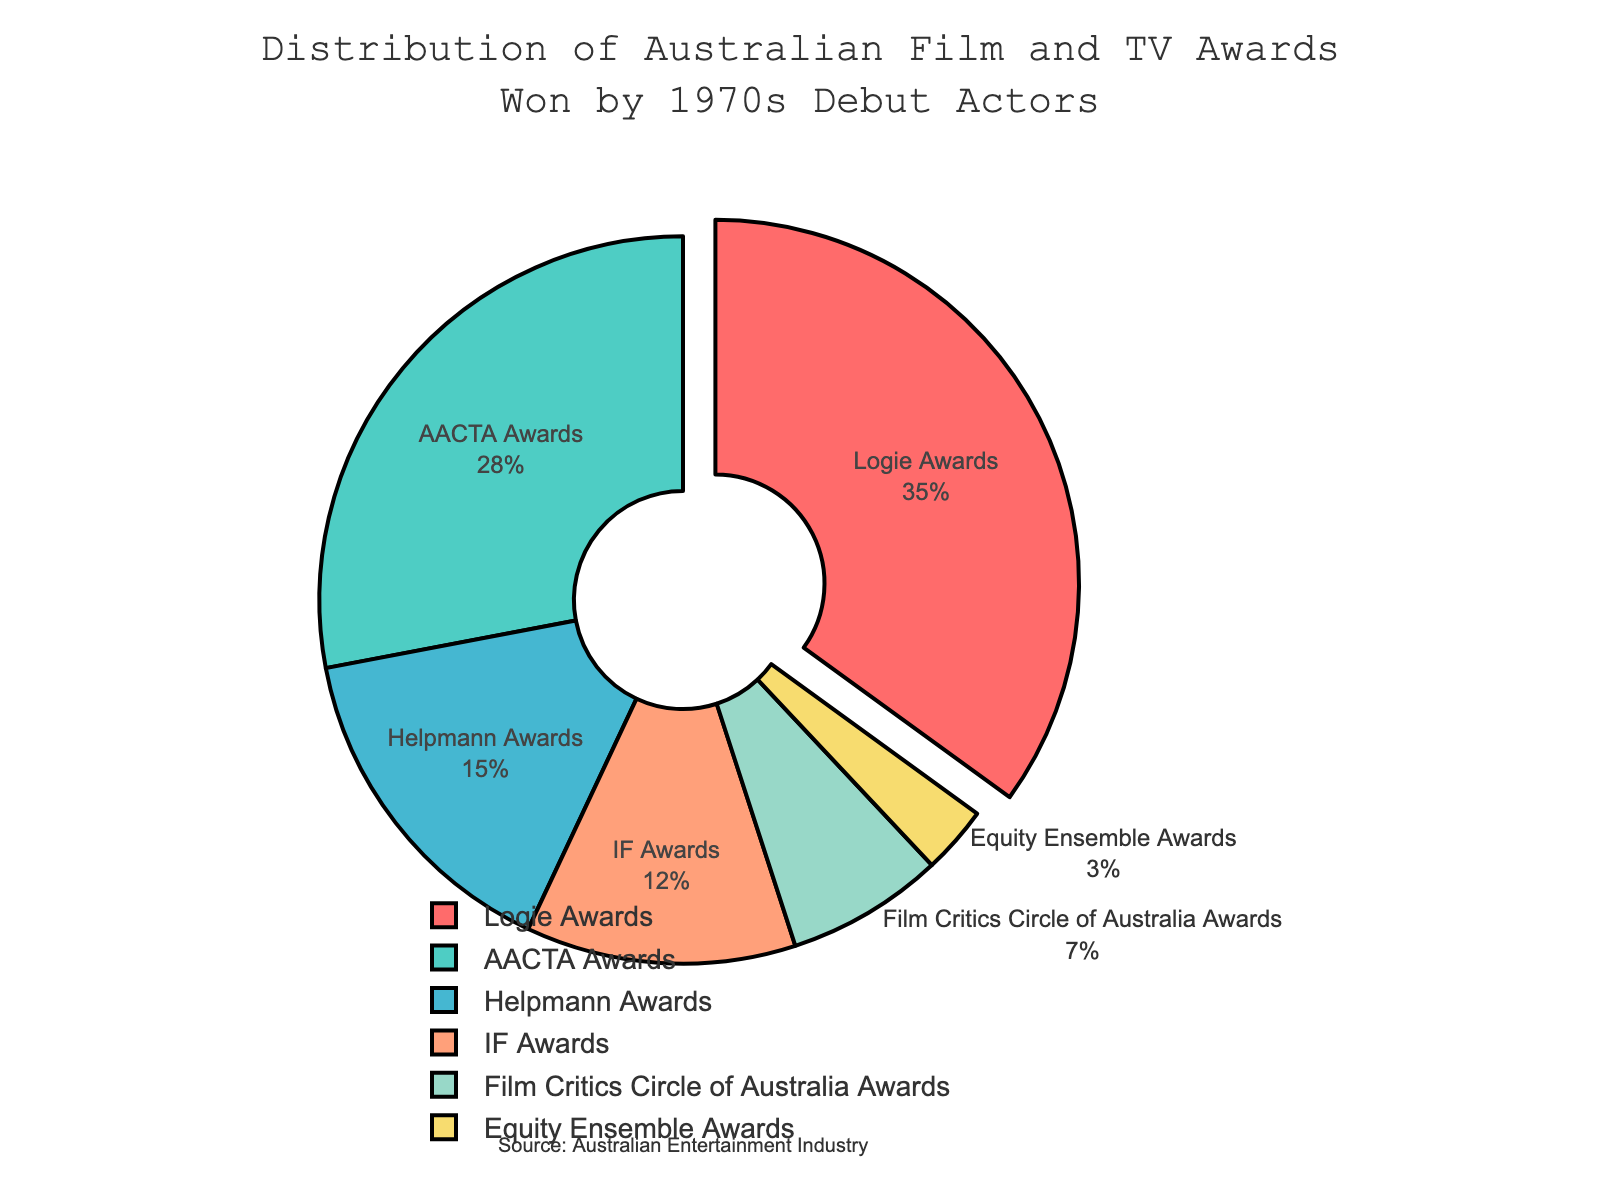What is the largest segment in the pie chart? The largest segment can be identified by visually comparing the sizes of the segments. The 'Logie Awards' segment is visually the largest and represents 35% of the distribution.
Answer: Logie Awards Which award has the second highest percentage? To find the second largest segment in terms of percentage, we look for the segment that is smaller than the largest but larger than the others. 'AACTA Awards' at 28% fits this criterion.
Answer: AACTA Awards What is the total percentage of awards represented by the top two segments combined? The top two segments are 'Logie Awards' and 'AACTA Awards' with percentages 35% and 28% respectively. Summing them up: 35% + 28% = 63%.
Answer: 63% How many awards have a percentage lower than 15%? By visually inspecting the chart, the awards with percentages lower than 15% are 'IF Awards' (12%), 'Film Critics Circle of Australia Awards' (7%), and 'Equity Ensemble Awards' (3%). There are three such awards.
Answer: 3 Which award is represented by the smallest segment in the pie chart? The smallest segment can be identified by visually comparing the sizes of the segments. 'Equity Ensemble Awards' is the smallest with only 3%.
Answer: Equity Ensemble Awards What is the difference in percentage between the 'Helpmann Awards' and 'IF Awards'? 'Helpmann Awards' have 15% and 'IF Awards' have 12%. The difference is calculated by subtracting the smaller percentage from the larger: 15% - 12% = 3%.
Answer: 3% How are 'Helpmann Awards' and 'AACTA Awards' visually distinguished in the chart? Both the 'Helpmann Awards' and 'AACTA Awards' segments have distinct colors and sizes. 'Helpmann Awards' are a smaller segment at 15% in a light green color, while 'AACTA Awards' are larger at 28% in a cyan color.
Answer: Color and segment size Which awards together make up less than 10% of the distribution? By checking the chart, 'Film Critics Circle of Australia Awards' with 7% and 'Equity Ensemble Awards' with 3% together make up 10%. However, individually, they are both below 10%.
Answer: Film Critics Circle of Australia Awards and Equity Ensemble Awards 